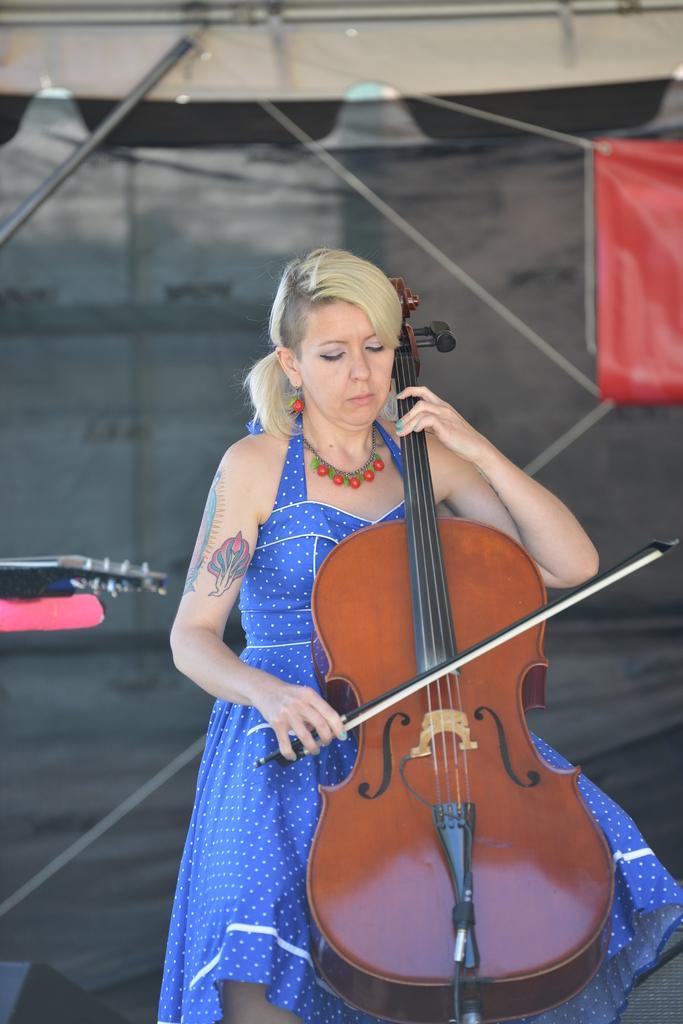Describe this image in one or two sentences. Women playing musical instrument. 